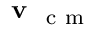Convert formula to latex. <formula><loc_0><loc_0><loc_500><loc_500>v _ { c m }</formula> 